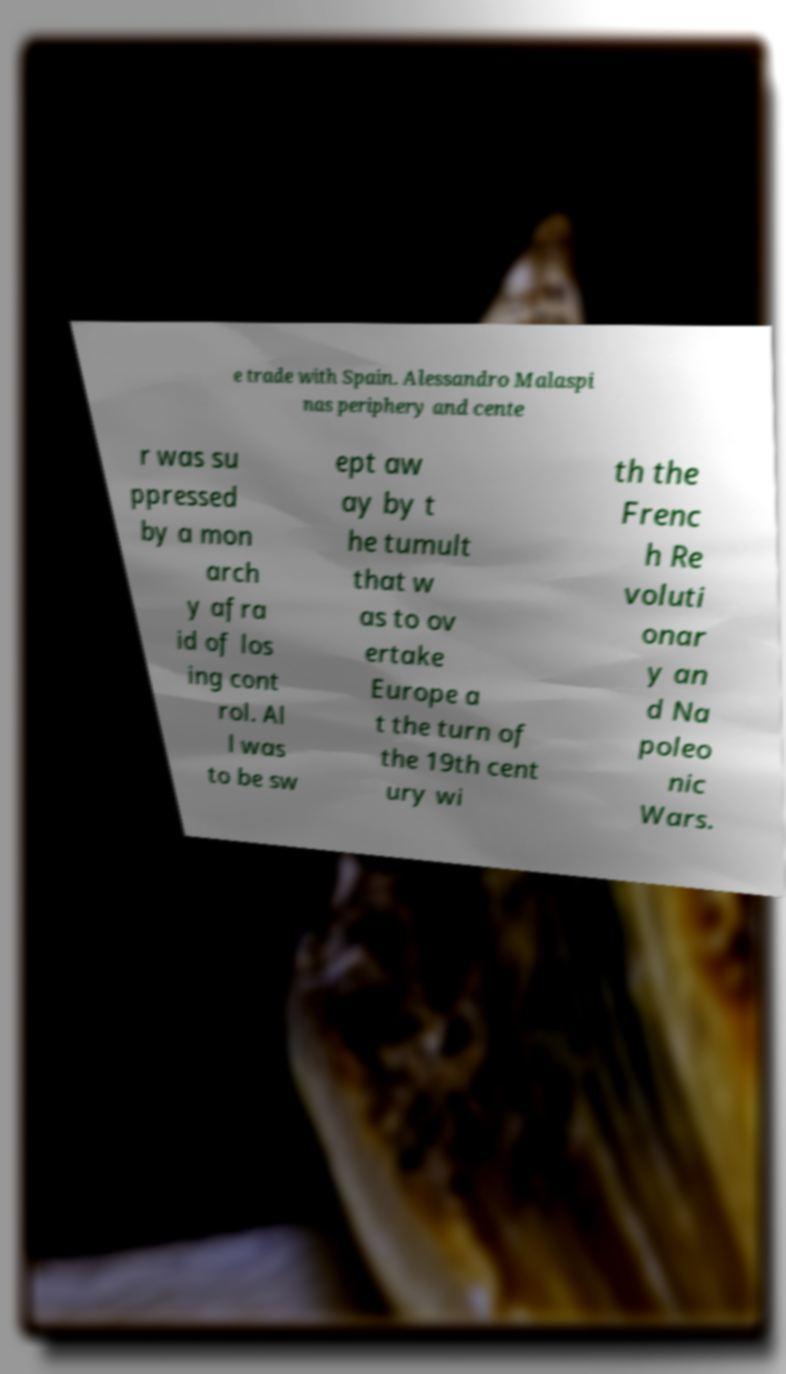For documentation purposes, I need the text within this image transcribed. Could you provide that? e trade with Spain. Alessandro Malaspi nas periphery and cente r was su ppressed by a mon arch y afra id of los ing cont rol. Al l was to be sw ept aw ay by t he tumult that w as to ov ertake Europe a t the turn of the 19th cent ury wi th the Frenc h Re voluti onar y an d Na poleo nic Wars. 